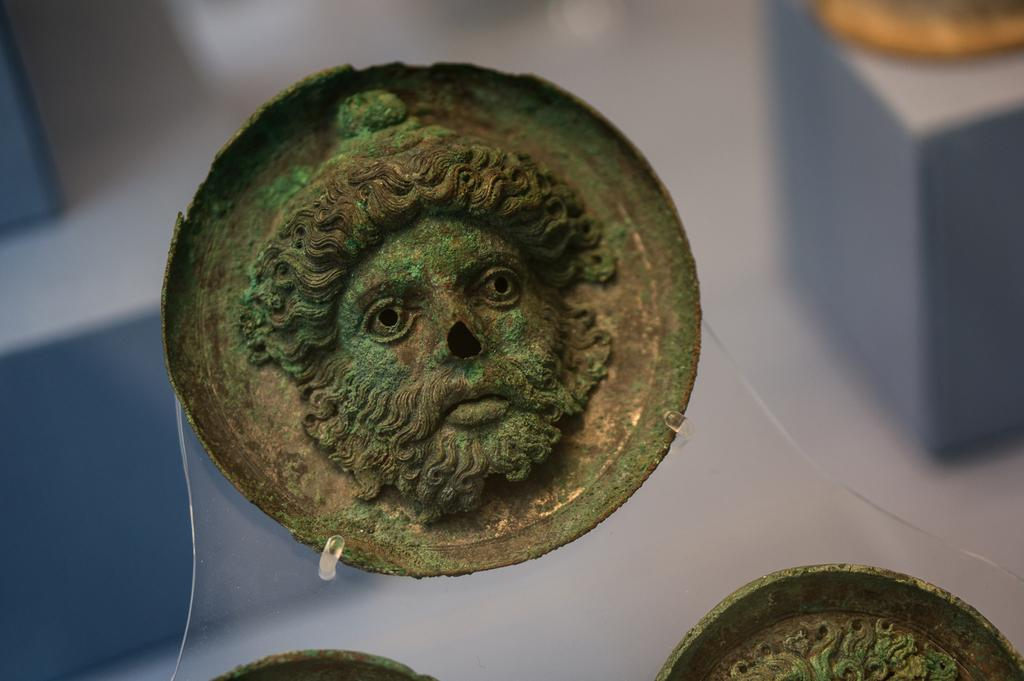What is the main subject of the image? There is a sculpture of a person in the image. Can you describe the shape of the sculpture? The sculpture is in a circular shape. Where is the sculpture located in the image? The sculpture is in the middle of the image. What can be seen in the background of the image? There are wooden things present in the background of the image. What type of idea is being expressed by the laborer in the image? There is no laborer present in the image, and therefore no idea can be attributed to a laborer. 